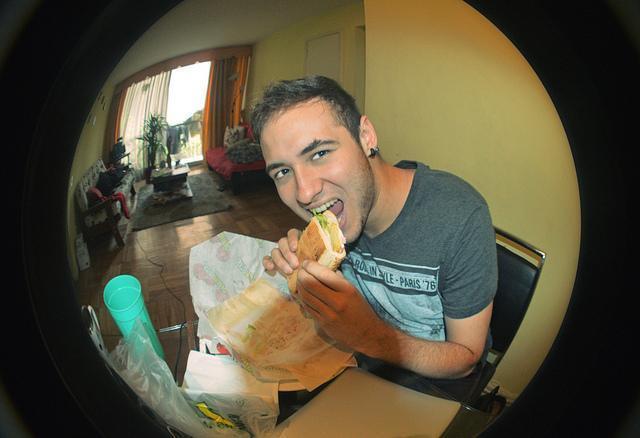How many couches are visible?
Give a very brief answer. 2. How many signs are hanging above the toilet that are not written in english?
Give a very brief answer. 0. 